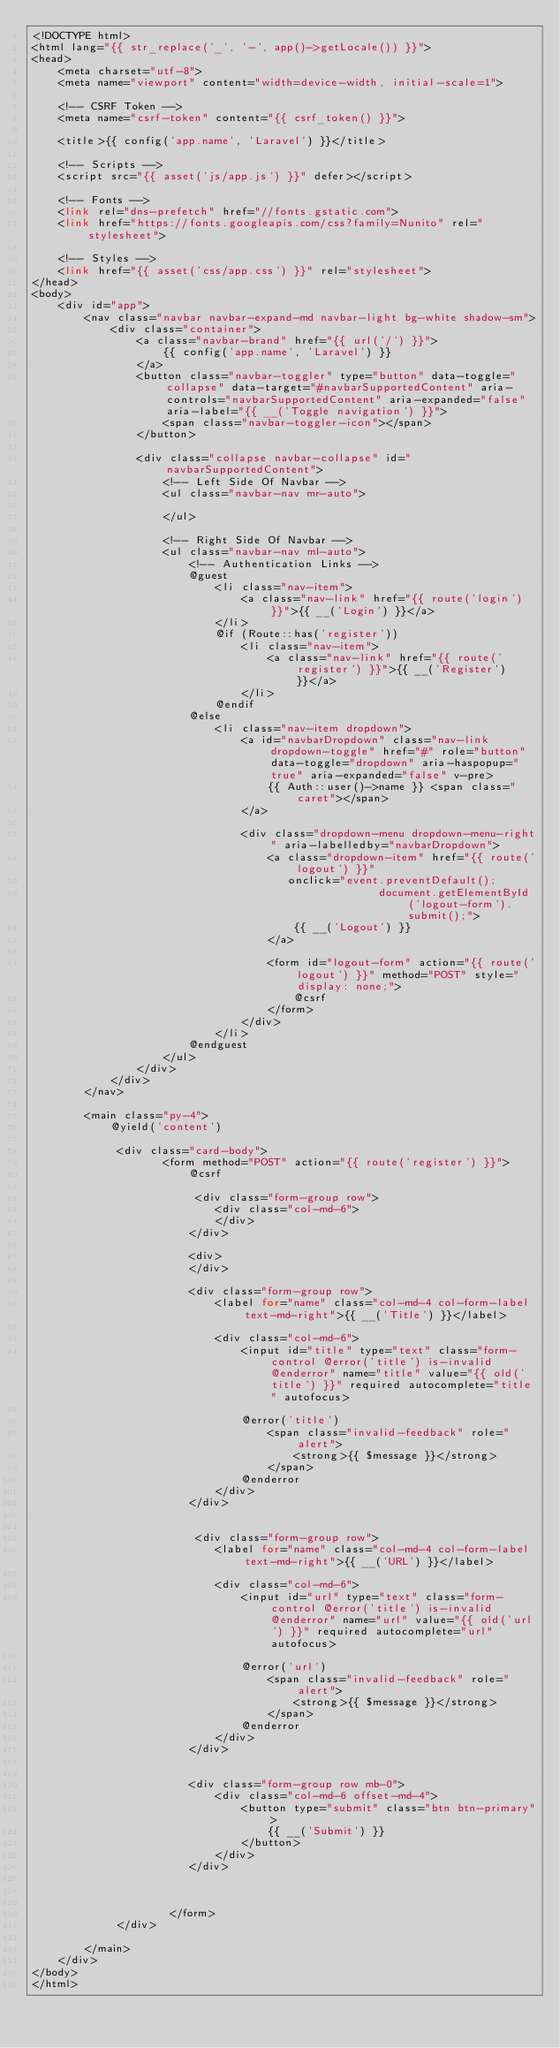Convert code to text. <code><loc_0><loc_0><loc_500><loc_500><_PHP_><!DOCTYPE html>
<html lang="{{ str_replace('_', '-', app()->getLocale()) }}">
<head>
    <meta charset="utf-8">
    <meta name="viewport" content="width=device-width, initial-scale=1">

    <!-- CSRF Token -->
    <meta name="csrf-token" content="{{ csrf_token() }}">

    <title>{{ config('app.name', 'Laravel') }}</title>

    <!-- Scripts -->
    <script src="{{ asset('js/app.js') }}" defer></script>

    <!-- Fonts -->
    <link rel="dns-prefetch" href="//fonts.gstatic.com">
    <link href="https://fonts.googleapis.com/css?family=Nunito" rel="stylesheet">

    <!-- Styles -->
    <link href="{{ asset('css/app.css') }}" rel="stylesheet">
</head>
<body>
    <div id="app">
        <nav class="navbar navbar-expand-md navbar-light bg-white shadow-sm">
            <div class="container">
                <a class="navbar-brand" href="{{ url('/') }}">
                    {{ config('app.name', 'Laravel') }}
                </a>
                <button class="navbar-toggler" type="button" data-toggle="collapse" data-target="#navbarSupportedContent" aria-controls="navbarSupportedContent" aria-expanded="false" aria-label="{{ __('Toggle navigation') }}">
                    <span class="navbar-toggler-icon"></span>
                </button>

                <div class="collapse navbar-collapse" id="navbarSupportedContent">
                    <!-- Left Side Of Navbar -->
                    <ul class="navbar-nav mr-auto">

                    </ul>

                    <!-- Right Side Of Navbar -->
                    <ul class="navbar-nav ml-auto">
                        <!-- Authentication Links -->
                        @guest
                            <li class="nav-item">
                                <a class="nav-link" href="{{ route('login') }}">{{ __('Login') }}</a>
                            </li>
                            @if (Route::has('register'))
                                <li class="nav-item">
                                    <a class="nav-link" href="{{ route('register') }}">{{ __('Register') }}</a>
                                </li>
                            @endif
                        @else
                            <li class="nav-item dropdown">
                                <a id="navbarDropdown" class="nav-link dropdown-toggle" href="#" role="button" data-toggle="dropdown" aria-haspopup="true" aria-expanded="false" v-pre>
                                    {{ Auth::user()->name }} <span class="caret"></span>
                                </a>

                                <div class="dropdown-menu dropdown-menu-right" aria-labelledby="navbarDropdown">
                                    <a class="dropdown-item" href="{{ route('logout') }}"
                                       onclick="event.preventDefault();
                                                     document.getElementById('logout-form').submit();">
                                        {{ __('Logout') }}
                                    </a>

                                    <form id="logout-form" action="{{ route('logout') }}" method="POST" style="display: none;">
                                        @csrf
                                    </form>
                                </div>
                            </li>
                        @endguest
                    </ul>
                </div>
            </div>
        </nav>

        <main class="py-4">
            @yield('content')
            
             <div class="card-body">
                    <form method="POST" action="{{ route('register') }}">
                        @csrf
                        
                         <div class="form-group row">
                            <div class="col-md-6">
                            </div>
                        </div>
                        
                        <div>
                        </div>

                        <div class="form-group row">
                            <label for="name" class="col-md-4 col-form-label text-md-right">{{ __('Title') }}</label>

                            <div class="col-md-6">
                                <input id="title" type="text" class="form-control @error('title') is-invalid @enderror" name="title" value="{{ old('title') }}" required autocomplete="title" autofocus>

                                @error('title')
                                    <span class="invalid-feedback" role="alert">
                                        <strong>{{ $message }}</strong>
                                    </span>
                                @enderror
                            </div>
                        </div>
                        
                        
                         <div class="form-group row">
                            <label for="name" class="col-md-4 col-form-label text-md-right">{{ __('URL') }}</label>

                            <div class="col-md-6">
                                <input id="url" type="text" class="form-control @error('title') is-invalid @enderror" name="url" value="{{ old('url') }}" required autocomplete="url" autofocus>

                                @error('url')
                                    <span class="invalid-feedback" role="alert">
                                        <strong>{{ $message }}</strong>
                                    </span>
                                @enderror
                            </div>
                        </div>
                        
                        
                        <div class="form-group row mb-0">
                            <div class="col-md-6 offset-md-4">
                                <button type="submit" class="btn btn-primary">
                                    {{ __('Submit') }}
                                </button>
                            </div>
                        </div>

                        
                        
                     </form>
             </div>           
            
        </main>
    </div>
</body>
</html>
</code> 